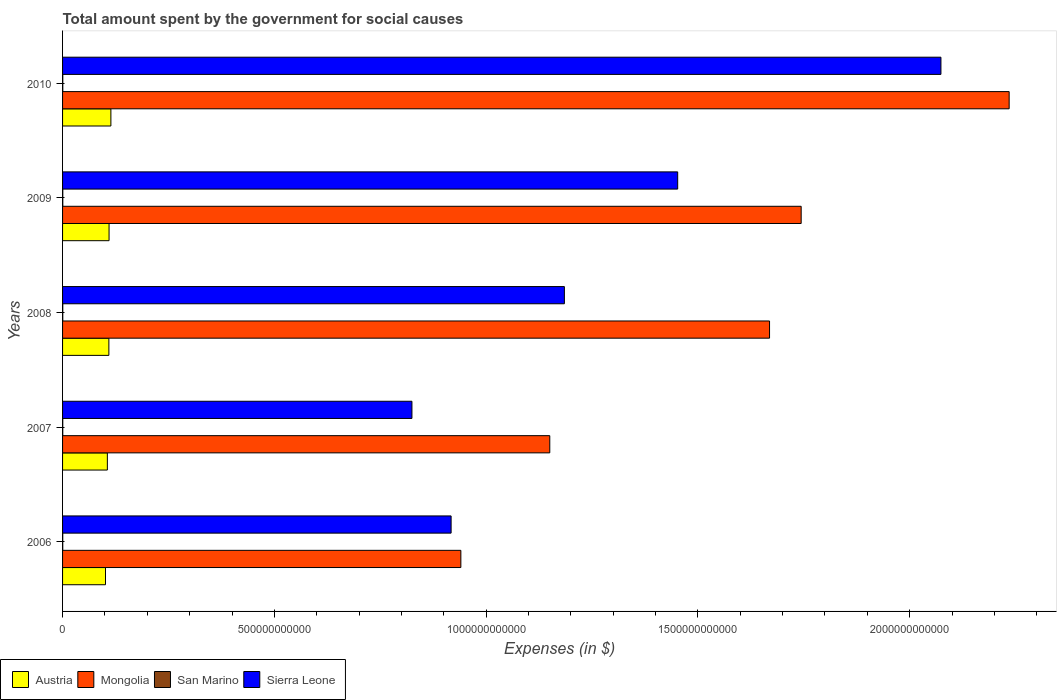How many groups of bars are there?
Provide a succinct answer. 5. Are the number of bars per tick equal to the number of legend labels?
Provide a short and direct response. Yes. How many bars are there on the 4th tick from the bottom?
Your answer should be very brief. 4. What is the label of the 3rd group of bars from the top?
Ensure brevity in your answer.  2008. In how many cases, is the number of bars for a given year not equal to the number of legend labels?
Provide a succinct answer. 0. What is the amount spent for social causes by the government in San Marino in 2009?
Your answer should be compact. 5.34e+08. Across all years, what is the maximum amount spent for social causes by the government in Austria?
Make the answer very short. 1.14e+11. Across all years, what is the minimum amount spent for social causes by the government in San Marino?
Your response must be concise. 4.46e+08. In which year was the amount spent for social causes by the government in San Marino maximum?
Your answer should be compact. 2009. In which year was the amount spent for social causes by the government in San Marino minimum?
Give a very brief answer. 2006. What is the total amount spent for social causes by the government in San Marino in the graph?
Your answer should be very brief. 2.50e+09. What is the difference between the amount spent for social causes by the government in Sierra Leone in 2006 and that in 2010?
Offer a very short reply. -1.16e+12. What is the difference between the amount spent for social causes by the government in San Marino in 2010 and the amount spent for social causes by the government in Sierra Leone in 2008?
Ensure brevity in your answer.  -1.18e+12. What is the average amount spent for social causes by the government in Austria per year?
Give a very brief answer. 1.08e+11. In the year 2006, what is the difference between the amount spent for social causes by the government in San Marino and amount spent for social causes by the government in Mongolia?
Your answer should be very brief. -9.40e+11. In how many years, is the amount spent for social causes by the government in Sierra Leone greater than 1200000000000 $?
Your answer should be very brief. 2. What is the ratio of the amount spent for social causes by the government in Sierra Leone in 2009 to that in 2010?
Your response must be concise. 0.7. What is the difference between the highest and the second highest amount spent for social causes by the government in San Marino?
Your answer should be very brief. 4.72e+06. What is the difference between the highest and the lowest amount spent for social causes by the government in Mongolia?
Your answer should be compact. 1.29e+12. Is the sum of the amount spent for social causes by the government in Mongolia in 2007 and 2009 greater than the maximum amount spent for social causes by the government in Austria across all years?
Your answer should be compact. Yes. What does the 1st bar from the top in 2007 represents?
Your response must be concise. Sierra Leone. What does the 1st bar from the bottom in 2010 represents?
Your answer should be very brief. Austria. What is the difference between two consecutive major ticks on the X-axis?
Ensure brevity in your answer.  5.00e+11. Are the values on the major ticks of X-axis written in scientific E-notation?
Make the answer very short. No. Does the graph contain any zero values?
Your response must be concise. No. Does the graph contain grids?
Give a very brief answer. No. How many legend labels are there?
Your answer should be compact. 4. How are the legend labels stacked?
Ensure brevity in your answer.  Horizontal. What is the title of the graph?
Offer a very short reply. Total amount spent by the government for social causes. What is the label or title of the X-axis?
Your answer should be compact. Expenses (in $). What is the label or title of the Y-axis?
Your answer should be compact. Years. What is the Expenses (in $) in Austria in 2006?
Your answer should be compact. 1.01e+11. What is the Expenses (in $) in Mongolia in 2006?
Ensure brevity in your answer.  9.40e+11. What is the Expenses (in $) in San Marino in 2006?
Your answer should be compact. 4.46e+08. What is the Expenses (in $) of Sierra Leone in 2006?
Your answer should be compact. 9.17e+11. What is the Expenses (in $) of Austria in 2007?
Your answer should be compact. 1.06e+11. What is the Expenses (in $) of Mongolia in 2007?
Keep it short and to the point. 1.15e+12. What is the Expenses (in $) in San Marino in 2007?
Your response must be concise. 4.86e+08. What is the Expenses (in $) of Sierra Leone in 2007?
Give a very brief answer. 8.25e+11. What is the Expenses (in $) in Austria in 2008?
Your answer should be very brief. 1.09e+11. What is the Expenses (in $) of Mongolia in 2008?
Provide a short and direct response. 1.67e+12. What is the Expenses (in $) in San Marino in 2008?
Provide a succinct answer. 5.02e+08. What is the Expenses (in $) in Sierra Leone in 2008?
Your answer should be compact. 1.18e+12. What is the Expenses (in $) in Austria in 2009?
Provide a short and direct response. 1.10e+11. What is the Expenses (in $) in Mongolia in 2009?
Offer a terse response. 1.74e+12. What is the Expenses (in $) of San Marino in 2009?
Your answer should be very brief. 5.34e+08. What is the Expenses (in $) in Sierra Leone in 2009?
Provide a short and direct response. 1.45e+12. What is the Expenses (in $) in Austria in 2010?
Your response must be concise. 1.14e+11. What is the Expenses (in $) in Mongolia in 2010?
Provide a short and direct response. 2.23e+12. What is the Expenses (in $) of San Marino in 2010?
Provide a short and direct response. 5.29e+08. What is the Expenses (in $) in Sierra Leone in 2010?
Offer a very short reply. 2.07e+12. Across all years, what is the maximum Expenses (in $) in Austria?
Give a very brief answer. 1.14e+11. Across all years, what is the maximum Expenses (in $) of Mongolia?
Provide a short and direct response. 2.23e+12. Across all years, what is the maximum Expenses (in $) in San Marino?
Your response must be concise. 5.34e+08. Across all years, what is the maximum Expenses (in $) of Sierra Leone?
Offer a very short reply. 2.07e+12. Across all years, what is the minimum Expenses (in $) of Austria?
Offer a terse response. 1.01e+11. Across all years, what is the minimum Expenses (in $) of Mongolia?
Offer a very short reply. 9.40e+11. Across all years, what is the minimum Expenses (in $) in San Marino?
Give a very brief answer. 4.46e+08. Across all years, what is the minimum Expenses (in $) of Sierra Leone?
Make the answer very short. 8.25e+11. What is the total Expenses (in $) of Austria in the graph?
Ensure brevity in your answer.  5.40e+11. What is the total Expenses (in $) of Mongolia in the graph?
Make the answer very short. 7.74e+12. What is the total Expenses (in $) in San Marino in the graph?
Make the answer very short. 2.50e+09. What is the total Expenses (in $) in Sierra Leone in the graph?
Offer a terse response. 6.45e+12. What is the difference between the Expenses (in $) in Austria in 2006 and that in 2007?
Offer a terse response. -4.40e+09. What is the difference between the Expenses (in $) in Mongolia in 2006 and that in 2007?
Offer a terse response. -2.10e+11. What is the difference between the Expenses (in $) in San Marino in 2006 and that in 2007?
Make the answer very short. -4.05e+07. What is the difference between the Expenses (in $) in Sierra Leone in 2006 and that in 2007?
Make the answer very short. 9.25e+1. What is the difference between the Expenses (in $) in Austria in 2006 and that in 2008?
Your answer should be compact. -7.98e+09. What is the difference between the Expenses (in $) in Mongolia in 2006 and that in 2008?
Ensure brevity in your answer.  -7.29e+11. What is the difference between the Expenses (in $) of San Marino in 2006 and that in 2008?
Offer a terse response. -5.62e+07. What is the difference between the Expenses (in $) in Sierra Leone in 2006 and that in 2008?
Keep it short and to the point. -2.67e+11. What is the difference between the Expenses (in $) in Austria in 2006 and that in 2009?
Ensure brevity in your answer.  -8.40e+09. What is the difference between the Expenses (in $) of Mongolia in 2006 and that in 2009?
Keep it short and to the point. -8.03e+11. What is the difference between the Expenses (in $) of San Marino in 2006 and that in 2009?
Make the answer very short. -8.82e+07. What is the difference between the Expenses (in $) in Sierra Leone in 2006 and that in 2009?
Offer a very short reply. -5.35e+11. What is the difference between the Expenses (in $) in Austria in 2006 and that in 2010?
Offer a terse response. -1.27e+1. What is the difference between the Expenses (in $) in Mongolia in 2006 and that in 2010?
Offer a terse response. -1.29e+12. What is the difference between the Expenses (in $) of San Marino in 2006 and that in 2010?
Offer a terse response. -8.35e+07. What is the difference between the Expenses (in $) in Sierra Leone in 2006 and that in 2010?
Your response must be concise. -1.16e+12. What is the difference between the Expenses (in $) in Austria in 2007 and that in 2008?
Give a very brief answer. -3.58e+09. What is the difference between the Expenses (in $) in Mongolia in 2007 and that in 2008?
Your answer should be very brief. -5.19e+11. What is the difference between the Expenses (in $) of San Marino in 2007 and that in 2008?
Your response must be concise. -1.57e+07. What is the difference between the Expenses (in $) in Sierra Leone in 2007 and that in 2008?
Give a very brief answer. -3.60e+11. What is the difference between the Expenses (in $) in Austria in 2007 and that in 2009?
Offer a very short reply. -4.00e+09. What is the difference between the Expenses (in $) in Mongolia in 2007 and that in 2009?
Offer a terse response. -5.94e+11. What is the difference between the Expenses (in $) in San Marino in 2007 and that in 2009?
Keep it short and to the point. -4.77e+07. What is the difference between the Expenses (in $) of Sierra Leone in 2007 and that in 2009?
Offer a very short reply. -6.27e+11. What is the difference between the Expenses (in $) of Austria in 2007 and that in 2010?
Give a very brief answer. -8.33e+09. What is the difference between the Expenses (in $) of Mongolia in 2007 and that in 2010?
Ensure brevity in your answer.  -1.08e+12. What is the difference between the Expenses (in $) of San Marino in 2007 and that in 2010?
Your answer should be very brief. -4.29e+07. What is the difference between the Expenses (in $) of Sierra Leone in 2007 and that in 2010?
Your answer should be compact. -1.25e+12. What is the difference between the Expenses (in $) in Austria in 2008 and that in 2009?
Provide a short and direct response. -4.19e+08. What is the difference between the Expenses (in $) of Mongolia in 2008 and that in 2009?
Give a very brief answer. -7.47e+1. What is the difference between the Expenses (in $) of San Marino in 2008 and that in 2009?
Your response must be concise. -3.20e+07. What is the difference between the Expenses (in $) of Sierra Leone in 2008 and that in 2009?
Your answer should be compact. -2.67e+11. What is the difference between the Expenses (in $) of Austria in 2008 and that in 2010?
Ensure brevity in your answer.  -4.75e+09. What is the difference between the Expenses (in $) of Mongolia in 2008 and that in 2010?
Your answer should be compact. -5.66e+11. What is the difference between the Expenses (in $) in San Marino in 2008 and that in 2010?
Provide a succinct answer. -2.73e+07. What is the difference between the Expenses (in $) in Sierra Leone in 2008 and that in 2010?
Give a very brief answer. -8.89e+11. What is the difference between the Expenses (in $) in Austria in 2009 and that in 2010?
Your answer should be compact. -4.33e+09. What is the difference between the Expenses (in $) in Mongolia in 2009 and that in 2010?
Ensure brevity in your answer.  -4.91e+11. What is the difference between the Expenses (in $) of San Marino in 2009 and that in 2010?
Provide a short and direct response. 4.72e+06. What is the difference between the Expenses (in $) in Sierra Leone in 2009 and that in 2010?
Make the answer very short. -6.22e+11. What is the difference between the Expenses (in $) in Austria in 2006 and the Expenses (in $) in Mongolia in 2007?
Provide a succinct answer. -1.05e+12. What is the difference between the Expenses (in $) of Austria in 2006 and the Expenses (in $) of San Marino in 2007?
Make the answer very short. 1.01e+11. What is the difference between the Expenses (in $) in Austria in 2006 and the Expenses (in $) in Sierra Leone in 2007?
Your response must be concise. -7.23e+11. What is the difference between the Expenses (in $) of Mongolia in 2006 and the Expenses (in $) of San Marino in 2007?
Provide a short and direct response. 9.40e+11. What is the difference between the Expenses (in $) in Mongolia in 2006 and the Expenses (in $) in Sierra Leone in 2007?
Provide a succinct answer. 1.16e+11. What is the difference between the Expenses (in $) of San Marino in 2006 and the Expenses (in $) of Sierra Leone in 2007?
Offer a very short reply. -8.24e+11. What is the difference between the Expenses (in $) in Austria in 2006 and the Expenses (in $) in Mongolia in 2008?
Provide a short and direct response. -1.57e+12. What is the difference between the Expenses (in $) of Austria in 2006 and the Expenses (in $) of San Marino in 2008?
Offer a very short reply. 1.01e+11. What is the difference between the Expenses (in $) of Austria in 2006 and the Expenses (in $) of Sierra Leone in 2008?
Keep it short and to the point. -1.08e+12. What is the difference between the Expenses (in $) in Mongolia in 2006 and the Expenses (in $) in San Marino in 2008?
Your response must be concise. 9.40e+11. What is the difference between the Expenses (in $) of Mongolia in 2006 and the Expenses (in $) of Sierra Leone in 2008?
Provide a succinct answer. -2.44e+11. What is the difference between the Expenses (in $) in San Marino in 2006 and the Expenses (in $) in Sierra Leone in 2008?
Your response must be concise. -1.18e+12. What is the difference between the Expenses (in $) of Austria in 2006 and the Expenses (in $) of Mongolia in 2009?
Offer a very short reply. -1.64e+12. What is the difference between the Expenses (in $) in Austria in 2006 and the Expenses (in $) in San Marino in 2009?
Offer a very short reply. 1.01e+11. What is the difference between the Expenses (in $) in Austria in 2006 and the Expenses (in $) in Sierra Leone in 2009?
Provide a short and direct response. -1.35e+12. What is the difference between the Expenses (in $) in Mongolia in 2006 and the Expenses (in $) in San Marino in 2009?
Make the answer very short. 9.40e+11. What is the difference between the Expenses (in $) in Mongolia in 2006 and the Expenses (in $) in Sierra Leone in 2009?
Your answer should be compact. -5.12e+11. What is the difference between the Expenses (in $) in San Marino in 2006 and the Expenses (in $) in Sierra Leone in 2009?
Offer a terse response. -1.45e+12. What is the difference between the Expenses (in $) of Austria in 2006 and the Expenses (in $) of Mongolia in 2010?
Keep it short and to the point. -2.13e+12. What is the difference between the Expenses (in $) of Austria in 2006 and the Expenses (in $) of San Marino in 2010?
Your answer should be very brief. 1.01e+11. What is the difference between the Expenses (in $) of Austria in 2006 and the Expenses (in $) of Sierra Leone in 2010?
Provide a succinct answer. -1.97e+12. What is the difference between the Expenses (in $) in Mongolia in 2006 and the Expenses (in $) in San Marino in 2010?
Your answer should be very brief. 9.40e+11. What is the difference between the Expenses (in $) in Mongolia in 2006 and the Expenses (in $) in Sierra Leone in 2010?
Provide a succinct answer. -1.13e+12. What is the difference between the Expenses (in $) in San Marino in 2006 and the Expenses (in $) in Sierra Leone in 2010?
Keep it short and to the point. -2.07e+12. What is the difference between the Expenses (in $) of Austria in 2007 and the Expenses (in $) of Mongolia in 2008?
Provide a succinct answer. -1.56e+12. What is the difference between the Expenses (in $) of Austria in 2007 and the Expenses (in $) of San Marino in 2008?
Offer a terse response. 1.05e+11. What is the difference between the Expenses (in $) in Austria in 2007 and the Expenses (in $) in Sierra Leone in 2008?
Provide a short and direct response. -1.08e+12. What is the difference between the Expenses (in $) of Mongolia in 2007 and the Expenses (in $) of San Marino in 2008?
Give a very brief answer. 1.15e+12. What is the difference between the Expenses (in $) in Mongolia in 2007 and the Expenses (in $) in Sierra Leone in 2008?
Provide a succinct answer. -3.45e+1. What is the difference between the Expenses (in $) in San Marino in 2007 and the Expenses (in $) in Sierra Leone in 2008?
Your answer should be very brief. -1.18e+12. What is the difference between the Expenses (in $) of Austria in 2007 and the Expenses (in $) of Mongolia in 2009?
Offer a very short reply. -1.64e+12. What is the difference between the Expenses (in $) of Austria in 2007 and the Expenses (in $) of San Marino in 2009?
Your answer should be very brief. 1.05e+11. What is the difference between the Expenses (in $) of Austria in 2007 and the Expenses (in $) of Sierra Leone in 2009?
Offer a terse response. -1.35e+12. What is the difference between the Expenses (in $) of Mongolia in 2007 and the Expenses (in $) of San Marino in 2009?
Ensure brevity in your answer.  1.15e+12. What is the difference between the Expenses (in $) of Mongolia in 2007 and the Expenses (in $) of Sierra Leone in 2009?
Offer a very short reply. -3.02e+11. What is the difference between the Expenses (in $) of San Marino in 2007 and the Expenses (in $) of Sierra Leone in 2009?
Provide a short and direct response. -1.45e+12. What is the difference between the Expenses (in $) in Austria in 2007 and the Expenses (in $) in Mongolia in 2010?
Keep it short and to the point. -2.13e+12. What is the difference between the Expenses (in $) of Austria in 2007 and the Expenses (in $) of San Marino in 2010?
Give a very brief answer. 1.05e+11. What is the difference between the Expenses (in $) in Austria in 2007 and the Expenses (in $) in Sierra Leone in 2010?
Offer a terse response. -1.97e+12. What is the difference between the Expenses (in $) of Mongolia in 2007 and the Expenses (in $) of San Marino in 2010?
Provide a short and direct response. 1.15e+12. What is the difference between the Expenses (in $) of Mongolia in 2007 and the Expenses (in $) of Sierra Leone in 2010?
Your answer should be very brief. -9.23e+11. What is the difference between the Expenses (in $) of San Marino in 2007 and the Expenses (in $) of Sierra Leone in 2010?
Provide a short and direct response. -2.07e+12. What is the difference between the Expenses (in $) in Austria in 2008 and the Expenses (in $) in Mongolia in 2009?
Ensure brevity in your answer.  -1.63e+12. What is the difference between the Expenses (in $) of Austria in 2008 and the Expenses (in $) of San Marino in 2009?
Offer a terse response. 1.09e+11. What is the difference between the Expenses (in $) in Austria in 2008 and the Expenses (in $) in Sierra Leone in 2009?
Your response must be concise. -1.34e+12. What is the difference between the Expenses (in $) of Mongolia in 2008 and the Expenses (in $) of San Marino in 2009?
Offer a very short reply. 1.67e+12. What is the difference between the Expenses (in $) of Mongolia in 2008 and the Expenses (in $) of Sierra Leone in 2009?
Provide a short and direct response. 2.17e+11. What is the difference between the Expenses (in $) of San Marino in 2008 and the Expenses (in $) of Sierra Leone in 2009?
Offer a terse response. -1.45e+12. What is the difference between the Expenses (in $) of Austria in 2008 and the Expenses (in $) of Mongolia in 2010?
Make the answer very short. -2.13e+12. What is the difference between the Expenses (in $) of Austria in 2008 and the Expenses (in $) of San Marino in 2010?
Provide a succinct answer. 1.09e+11. What is the difference between the Expenses (in $) of Austria in 2008 and the Expenses (in $) of Sierra Leone in 2010?
Make the answer very short. -1.96e+12. What is the difference between the Expenses (in $) in Mongolia in 2008 and the Expenses (in $) in San Marino in 2010?
Your answer should be very brief. 1.67e+12. What is the difference between the Expenses (in $) of Mongolia in 2008 and the Expenses (in $) of Sierra Leone in 2010?
Provide a short and direct response. -4.05e+11. What is the difference between the Expenses (in $) in San Marino in 2008 and the Expenses (in $) in Sierra Leone in 2010?
Your response must be concise. -2.07e+12. What is the difference between the Expenses (in $) of Austria in 2009 and the Expenses (in $) of Mongolia in 2010?
Keep it short and to the point. -2.13e+12. What is the difference between the Expenses (in $) in Austria in 2009 and the Expenses (in $) in San Marino in 2010?
Make the answer very short. 1.09e+11. What is the difference between the Expenses (in $) of Austria in 2009 and the Expenses (in $) of Sierra Leone in 2010?
Make the answer very short. -1.96e+12. What is the difference between the Expenses (in $) of Mongolia in 2009 and the Expenses (in $) of San Marino in 2010?
Give a very brief answer. 1.74e+12. What is the difference between the Expenses (in $) in Mongolia in 2009 and the Expenses (in $) in Sierra Leone in 2010?
Provide a succinct answer. -3.30e+11. What is the difference between the Expenses (in $) in San Marino in 2009 and the Expenses (in $) in Sierra Leone in 2010?
Your response must be concise. -2.07e+12. What is the average Expenses (in $) in Austria per year?
Make the answer very short. 1.08e+11. What is the average Expenses (in $) of Mongolia per year?
Your response must be concise. 1.55e+12. What is the average Expenses (in $) of San Marino per year?
Your answer should be very brief. 4.99e+08. What is the average Expenses (in $) of Sierra Leone per year?
Provide a succinct answer. 1.29e+12. In the year 2006, what is the difference between the Expenses (in $) of Austria and Expenses (in $) of Mongolia?
Offer a terse response. -8.39e+11. In the year 2006, what is the difference between the Expenses (in $) of Austria and Expenses (in $) of San Marino?
Give a very brief answer. 1.01e+11. In the year 2006, what is the difference between the Expenses (in $) in Austria and Expenses (in $) in Sierra Leone?
Your answer should be compact. -8.16e+11. In the year 2006, what is the difference between the Expenses (in $) of Mongolia and Expenses (in $) of San Marino?
Keep it short and to the point. 9.40e+11. In the year 2006, what is the difference between the Expenses (in $) in Mongolia and Expenses (in $) in Sierra Leone?
Your answer should be very brief. 2.30e+1. In the year 2006, what is the difference between the Expenses (in $) in San Marino and Expenses (in $) in Sierra Leone?
Offer a very short reply. -9.17e+11. In the year 2007, what is the difference between the Expenses (in $) in Austria and Expenses (in $) in Mongolia?
Offer a terse response. -1.04e+12. In the year 2007, what is the difference between the Expenses (in $) of Austria and Expenses (in $) of San Marino?
Keep it short and to the point. 1.05e+11. In the year 2007, what is the difference between the Expenses (in $) in Austria and Expenses (in $) in Sierra Leone?
Offer a very short reply. -7.19e+11. In the year 2007, what is the difference between the Expenses (in $) in Mongolia and Expenses (in $) in San Marino?
Provide a succinct answer. 1.15e+12. In the year 2007, what is the difference between the Expenses (in $) in Mongolia and Expenses (in $) in Sierra Leone?
Keep it short and to the point. 3.25e+11. In the year 2007, what is the difference between the Expenses (in $) in San Marino and Expenses (in $) in Sierra Leone?
Your answer should be compact. -8.24e+11. In the year 2008, what is the difference between the Expenses (in $) of Austria and Expenses (in $) of Mongolia?
Provide a short and direct response. -1.56e+12. In the year 2008, what is the difference between the Expenses (in $) in Austria and Expenses (in $) in San Marino?
Give a very brief answer. 1.09e+11. In the year 2008, what is the difference between the Expenses (in $) in Austria and Expenses (in $) in Sierra Leone?
Your answer should be very brief. -1.08e+12. In the year 2008, what is the difference between the Expenses (in $) of Mongolia and Expenses (in $) of San Marino?
Your answer should be compact. 1.67e+12. In the year 2008, what is the difference between the Expenses (in $) of Mongolia and Expenses (in $) of Sierra Leone?
Offer a terse response. 4.84e+11. In the year 2008, what is the difference between the Expenses (in $) in San Marino and Expenses (in $) in Sierra Leone?
Your answer should be very brief. -1.18e+12. In the year 2009, what is the difference between the Expenses (in $) of Austria and Expenses (in $) of Mongolia?
Give a very brief answer. -1.63e+12. In the year 2009, what is the difference between the Expenses (in $) of Austria and Expenses (in $) of San Marino?
Offer a terse response. 1.09e+11. In the year 2009, what is the difference between the Expenses (in $) in Austria and Expenses (in $) in Sierra Leone?
Offer a terse response. -1.34e+12. In the year 2009, what is the difference between the Expenses (in $) of Mongolia and Expenses (in $) of San Marino?
Offer a very short reply. 1.74e+12. In the year 2009, what is the difference between the Expenses (in $) of Mongolia and Expenses (in $) of Sierra Leone?
Make the answer very short. 2.92e+11. In the year 2009, what is the difference between the Expenses (in $) of San Marino and Expenses (in $) of Sierra Leone?
Your response must be concise. -1.45e+12. In the year 2010, what is the difference between the Expenses (in $) in Austria and Expenses (in $) in Mongolia?
Offer a terse response. -2.12e+12. In the year 2010, what is the difference between the Expenses (in $) of Austria and Expenses (in $) of San Marino?
Ensure brevity in your answer.  1.14e+11. In the year 2010, what is the difference between the Expenses (in $) in Austria and Expenses (in $) in Sierra Leone?
Offer a very short reply. -1.96e+12. In the year 2010, what is the difference between the Expenses (in $) in Mongolia and Expenses (in $) in San Marino?
Offer a terse response. 2.23e+12. In the year 2010, what is the difference between the Expenses (in $) in Mongolia and Expenses (in $) in Sierra Leone?
Keep it short and to the point. 1.61e+11. In the year 2010, what is the difference between the Expenses (in $) of San Marino and Expenses (in $) of Sierra Leone?
Your answer should be compact. -2.07e+12. What is the ratio of the Expenses (in $) of Austria in 2006 to that in 2007?
Make the answer very short. 0.96. What is the ratio of the Expenses (in $) of Mongolia in 2006 to that in 2007?
Offer a terse response. 0.82. What is the ratio of the Expenses (in $) of Sierra Leone in 2006 to that in 2007?
Offer a terse response. 1.11. What is the ratio of the Expenses (in $) of Austria in 2006 to that in 2008?
Make the answer very short. 0.93. What is the ratio of the Expenses (in $) in Mongolia in 2006 to that in 2008?
Offer a very short reply. 0.56. What is the ratio of the Expenses (in $) of San Marino in 2006 to that in 2008?
Keep it short and to the point. 0.89. What is the ratio of the Expenses (in $) in Sierra Leone in 2006 to that in 2008?
Ensure brevity in your answer.  0.77. What is the ratio of the Expenses (in $) of Austria in 2006 to that in 2009?
Provide a succinct answer. 0.92. What is the ratio of the Expenses (in $) in Mongolia in 2006 to that in 2009?
Offer a very short reply. 0.54. What is the ratio of the Expenses (in $) of San Marino in 2006 to that in 2009?
Keep it short and to the point. 0.83. What is the ratio of the Expenses (in $) of Sierra Leone in 2006 to that in 2009?
Offer a terse response. 0.63. What is the ratio of the Expenses (in $) in Austria in 2006 to that in 2010?
Keep it short and to the point. 0.89. What is the ratio of the Expenses (in $) in Mongolia in 2006 to that in 2010?
Your answer should be very brief. 0.42. What is the ratio of the Expenses (in $) in San Marino in 2006 to that in 2010?
Offer a terse response. 0.84. What is the ratio of the Expenses (in $) of Sierra Leone in 2006 to that in 2010?
Make the answer very short. 0.44. What is the ratio of the Expenses (in $) of Austria in 2007 to that in 2008?
Provide a short and direct response. 0.97. What is the ratio of the Expenses (in $) in Mongolia in 2007 to that in 2008?
Keep it short and to the point. 0.69. What is the ratio of the Expenses (in $) in San Marino in 2007 to that in 2008?
Make the answer very short. 0.97. What is the ratio of the Expenses (in $) of Sierra Leone in 2007 to that in 2008?
Offer a terse response. 0.7. What is the ratio of the Expenses (in $) in Austria in 2007 to that in 2009?
Your response must be concise. 0.96. What is the ratio of the Expenses (in $) of Mongolia in 2007 to that in 2009?
Your response must be concise. 0.66. What is the ratio of the Expenses (in $) of San Marino in 2007 to that in 2009?
Your answer should be very brief. 0.91. What is the ratio of the Expenses (in $) in Sierra Leone in 2007 to that in 2009?
Ensure brevity in your answer.  0.57. What is the ratio of the Expenses (in $) of Austria in 2007 to that in 2010?
Provide a short and direct response. 0.93. What is the ratio of the Expenses (in $) in Mongolia in 2007 to that in 2010?
Ensure brevity in your answer.  0.51. What is the ratio of the Expenses (in $) of San Marino in 2007 to that in 2010?
Give a very brief answer. 0.92. What is the ratio of the Expenses (in $) of Sierra Leone in 2007 to that in 2010?
Give a very brief answer. 0.4. What is the ratio of the Expenses (in $) of Austria in 2008 to that in 2009?
Your response must be concise. 1. What is the ratio of the Expenses (in $) of Mongolia in 2008 to that in 2009?
Make the answer very short. 0.96. What is the ratio of the Expenses (in $) of San Marino in 2008 to that in 2009?
Offer a very short reply. 0.94. What is the ratio of the Expenses (in $) of Sierra Leone in 2008 to that in 2009?
Offer a terse response. 0.82. What is the ratio of the Expenses (in $) in Austria in 2008 to that in 2010?
Ensure brevity in your answer.  0.96. What is the ratio of the Expenses (in $) in Mongolia in 2008 to that in 2010?
Provide a succinct answer. 0.75. What is the ratio of the Expenses (in $) of San Marino in 2008 to that in 2010?
Give a very brief answer. 0.95. What is the ratio of the Expenses (in $) in Sierra Leone in 2008 to that in 2010?
Ensure brevity in your answer.  0.57. What is the ratio of the Expenses (in $) in Austria in 2009 to that in 2010?
Give a very brief answer. 0.96. What is the ratio of the Expenses (in $) in Mongolia in 2009 to that in 2010?
Keep it short and to the point. 0.78. What is the ratio of the Expenses (in $) of San Marino in 2009 to that in 2010?
Give a very brief answer. 1.01. What is the ratio of the Expenses (in $) of Sierra Leone in 2009 to that in 2010?
Your answer should be compact. 0.7. What is the difference between the highest and the second highest Expenses (in $) of Austria?
Ensure brevity in your answer.  4.33e+09. What is the difference between the highest and the second highest Expenses (in $) in Mongolia?
Offer a very short reply. 4.91e+11. What is the difference between the highest and the second highest Expenses (in $) in San Marino?
Offer a very short reply. 4.72e+06. What is the difference between the highest and the second highest Expenses (in $) in Sierra Leone?
Offer a very short reply. 6.22e+11. What is the difference between the highest and the lowest Expenses (in $) in Austria?
Your answer should be very brief. 1.27e+1. What is the difference between the highest and the lowest Expenses (in $) in Mongolia?
Your answer should be very brief. 1.29e+12. What is the difference between the highest and the lowest Expenses (in $) in San Marino?
Provide a short and direct response. 8.82e+07. What is the difference between the highest and the lowest Expenses (in $) in Sierra Leone?
Keep it short and to the point. 1.25e+12. 